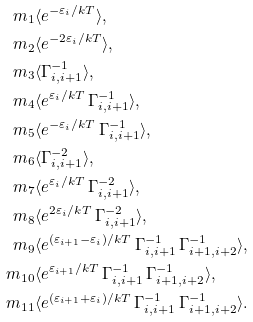<formula> <loc_0><loc_0><loc_500><loc_500>m _ { 1 } & \langle e ^ { - \varepsilon _ { i } / k T } \rangle , \\ m _ { 2 } & \langle e ^ { - 2 \varepsilon _ { i } / k T } \rangle , \\ m _ { 3 } & \langle \Gamma _ { i , i + 1 } ^ { - 1 } \rangle , \\ m _ { 4 } & \langle e ^ { \varepsilon _ { i } / k T } \, \Gamma _ { i , i + 1 } ^ { - 1 } \rangle , \\ m _ { 5 } & \langle e ^ { - \varepsilon _ { i } / k T } \, \Gamma _ { i , i + 1 } ^ { - 1 } \rangle , \\ m _ { 6 } & \langle \Gamma _ { i , i + 1 } ^ { - 2 } \rangle , \\ m _ { 7 } & \langle e ^ { \varepsilon _ { i } / k T } \, \Gamma _ { i , i + 1 } ^ { - 2 } \rangle , \\ m _ { 8 } & \langle e ^ { 2 \varepsilon _ { i } / k T } \, \Gamma _ { i , i + 1 } ^ { - 2 } \rangle , \\ m _ { 9 } & \langle e ^ { ( \varepsilon _ { i + 1 } - \varepsilon _ { i } ) / k T } \, \Gamma _ { i , i + 1 } ^ { - 1 } \, \Gamma _ { i + 1 , i + 2 } ^ { - 1 } \rangle , \\ m _ { 1 0 } & \langle e ^ { \varepsilon _ { i + 1 } / k T } \, \Gamma _ { i , i + 1 } ^ { - 1 } \, \Gamma _ { i + 1 , i + 2 } ^ { - 1 } \rangle , \\ m _ { 1 1 } & \langle e ^ { ( \varepsilon _ { i + 1 } + \varepsilon _ { i } ) / k T } \, \Gamma _ { i , i + 1 } ^ { - 1 } \, \Gamma _ { i + 1 , i + 2 } ^ { - 1 } \rangle .</formula> 